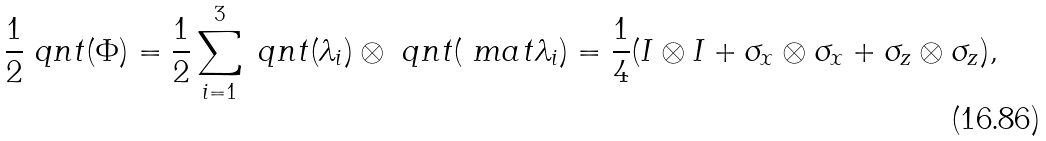Convert formula to latex. <formula><loc_0><loc_0><loc_500><loc_500>\frac { 1 } { 2 } \ q n t ( \Phi ) = \frac { 1 } { 2 } \sum _ { i = 1 } ^ { 3 } \ q n t ( \lambda _ { i } ) \otimes \ q n t ( \ m a t \lambda _ { i } ) = \frac { 1 } { 4 } ( I \otimes I + \sigma _ { x } \otimes \sigma _ { x } + \sigma _ { z } \otimes \sigma _ { z } ) ,</formula> 